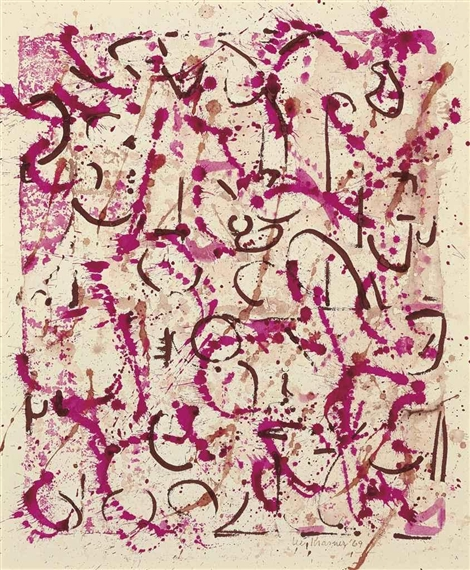Do you see any hidden patterns or shapes within the artwork? Upon closer inspection, the artwork seems to reveal hidden patterns and shapes arising from the interplay of lines and splatters. Some viewers might notice the semblance of faces or figures emerging from the abstract forms, as the curves and angles occasionally align to create human-like shapes or symbols. There are sections where the lines converge to form circular motifs or repetitive patterns, suggesting deliberate placements. These hidden shapes invite viewers to engage deeply with the piece, discovering personal symbols or meanings embedded within the chaos. Imagine this artwork is a map of a new, fantastical city. Describe the city. Envisioning this artwork as a map of a fantastical city, one can imagine a sprawling metropolis unlike any conventional urban landscape. The bold pink lines represent bustling thoroughfares, teeming with energy and life, while the black lines outline towering structures that stretch into the sky. This city has no defined blocks but organic, flowing districts, each pulsating with its unique rhythm. There are areas where the splatters create vibrant parks and open spaces, filled with abstract sculptures and innovation hubs. The city is alive with creativity, its inhabitants moving in a harmonious dance that reflects the spontaneous yet purposeful strokes of the map. Every corner is a blend of chaos and beauty, revealing new and exciting paths to discover. If you could add another element to this painting, what would it be? If I could add another element to this painting, it would be subtle touches of gold leaf. The gold would add a layer of luminosity and richness, providing a delicate contrast to the stark pink and black splatters. It would catch the light in different ways, depending on the viewing angle, adding depth and an element of surprise to the composition. The gold touches could be sparse yet deliberately placed, enhancing the sense of wonder and elegance within the energetic chaos of the artwork. 